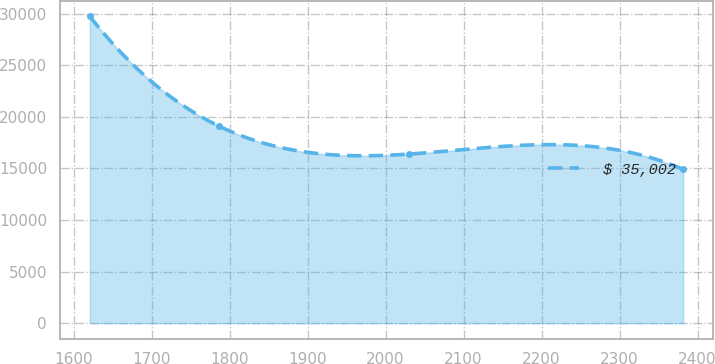Convert chart. <chart><loc_0><loc_0><loc_500><loc_500><line_chart><ecel><fcel>$ 35,002<nl><fcel>1620.84<fcel>29742.9<nl><fcel>1786.66<fcel>19094.6<nl><fcel>2029.82<fcel>16395<nl><fcel>2381.57<fcel>14911.9<nl></chart> 